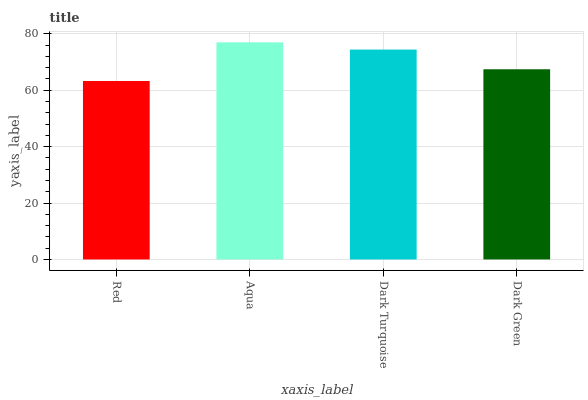Is Red the minimum?
Answer yes or no. Yes. Is Aqua the maximum?
Answer yes or no. Yes. Is Dark Turquoise the minimum?
Answer yes or no. No. Is Dark Turquoise the maximum?
Answer yes or no. No. Is Aqua greater than Dark Turquoise?
Answer yes or no. Yes. Is Dark Turquoise less than Aqua?
Answer yes or no. Yes. Is Dark Turquoise greater than Aqua?
Answer yes or no. No. Is Aqua less than Dark Turquoise?
Answer yes or no. No. Is Dark Turquoise the high median?
Answer yes or no. Yes. Is Dark Green the low median?
Answer yes or no. Yes. Is Red the high median?
Answer yes or no. No. Is Red the low median?
Answer yes or no. No. 